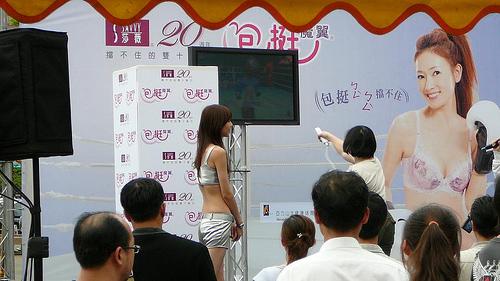What color are the girls shorts?
Give a very brief answer. Silver. What is the nationality of these people?
Be succinct. Asian. What game are they playing?
Concise answer only. Wii. 